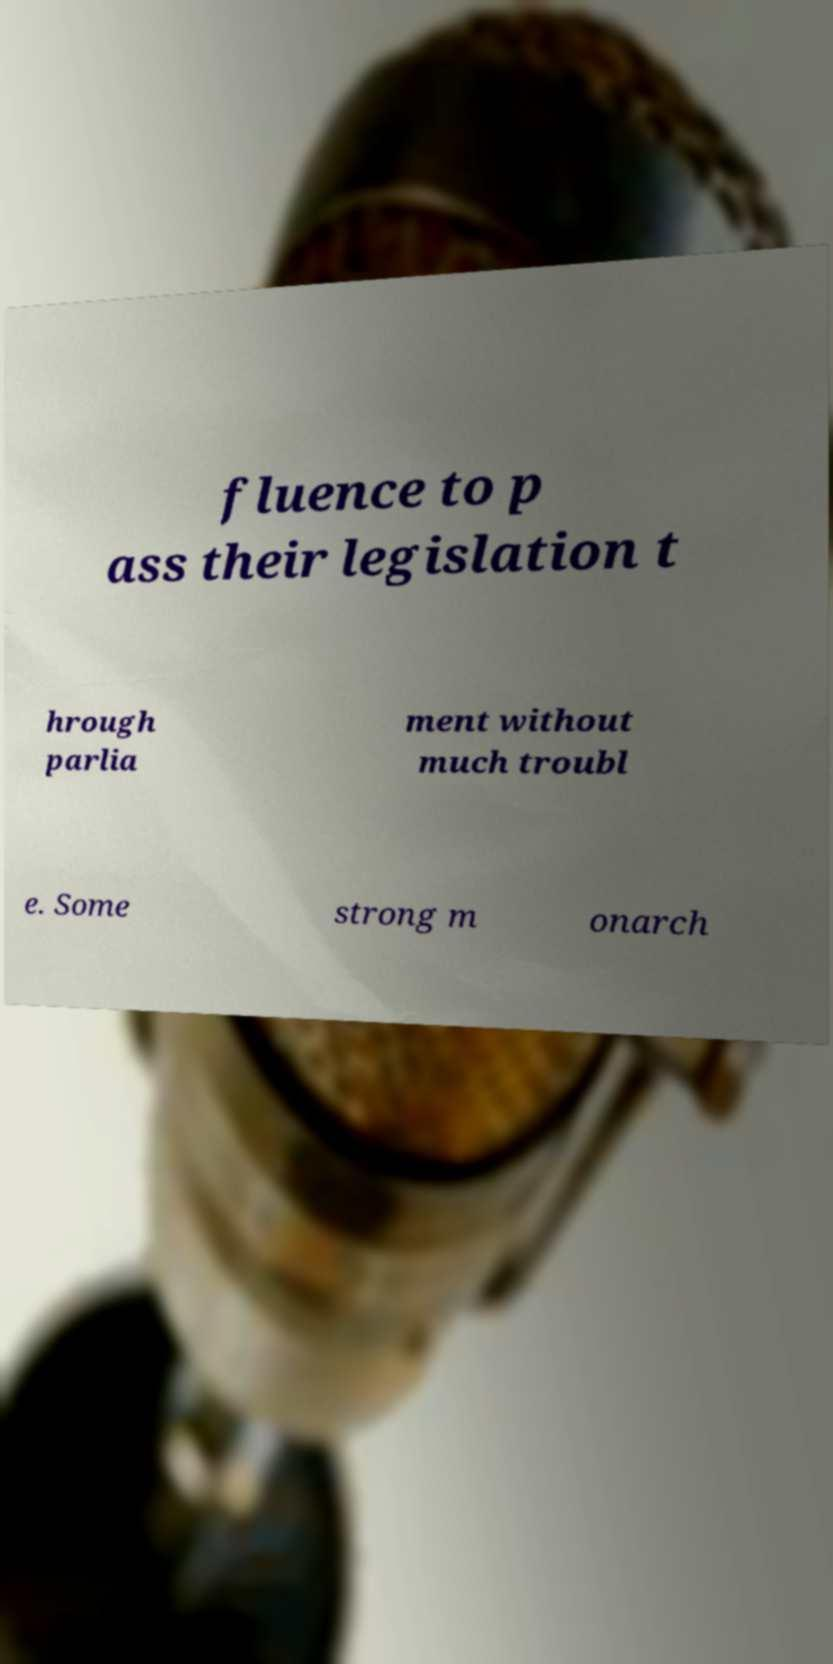Can you read and provide the text displayed in the image?This photo seems to have some interesting text. Can you extract and type it out for me? fluence to p ass their legislation t hrough parlia ment without much troubl e. Some strong m onarch 